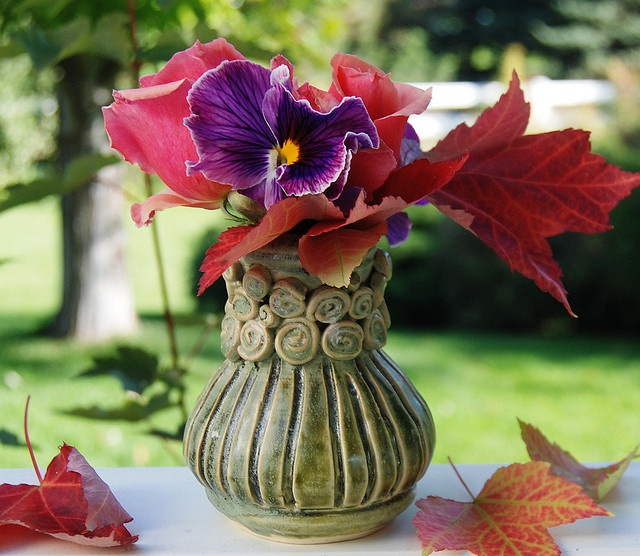Describe the objects in this image and their specific colors. I can see a vase in darkgreen, black, gray, and olive tones in this image. 